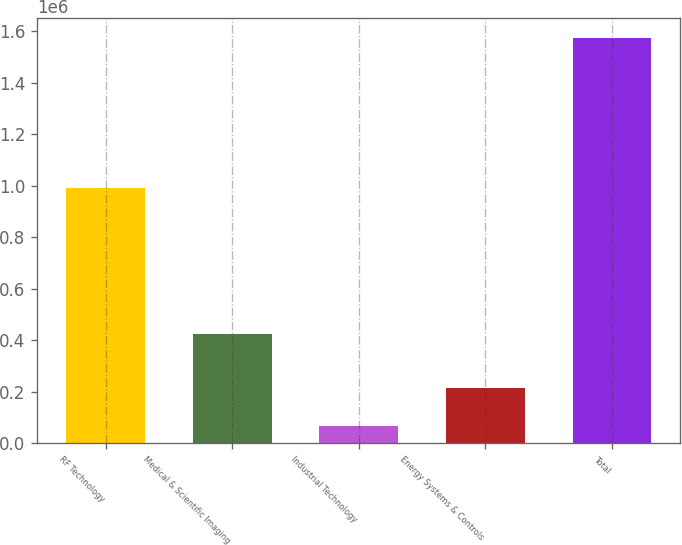Convert chart. <chart><loc_0><loc_0><loc_500><loc_500><bar_chart><fcel>RF Technology<fcel>Medical & Scientific Imaging<fcel>Industrial Technology<fcel>Energy Systems & Controls<fcel>Total<nl><fcel>991212<fcel>423616<fcel>65259<fcel>215973<fcel>1.5724e+06<nl></chart> 